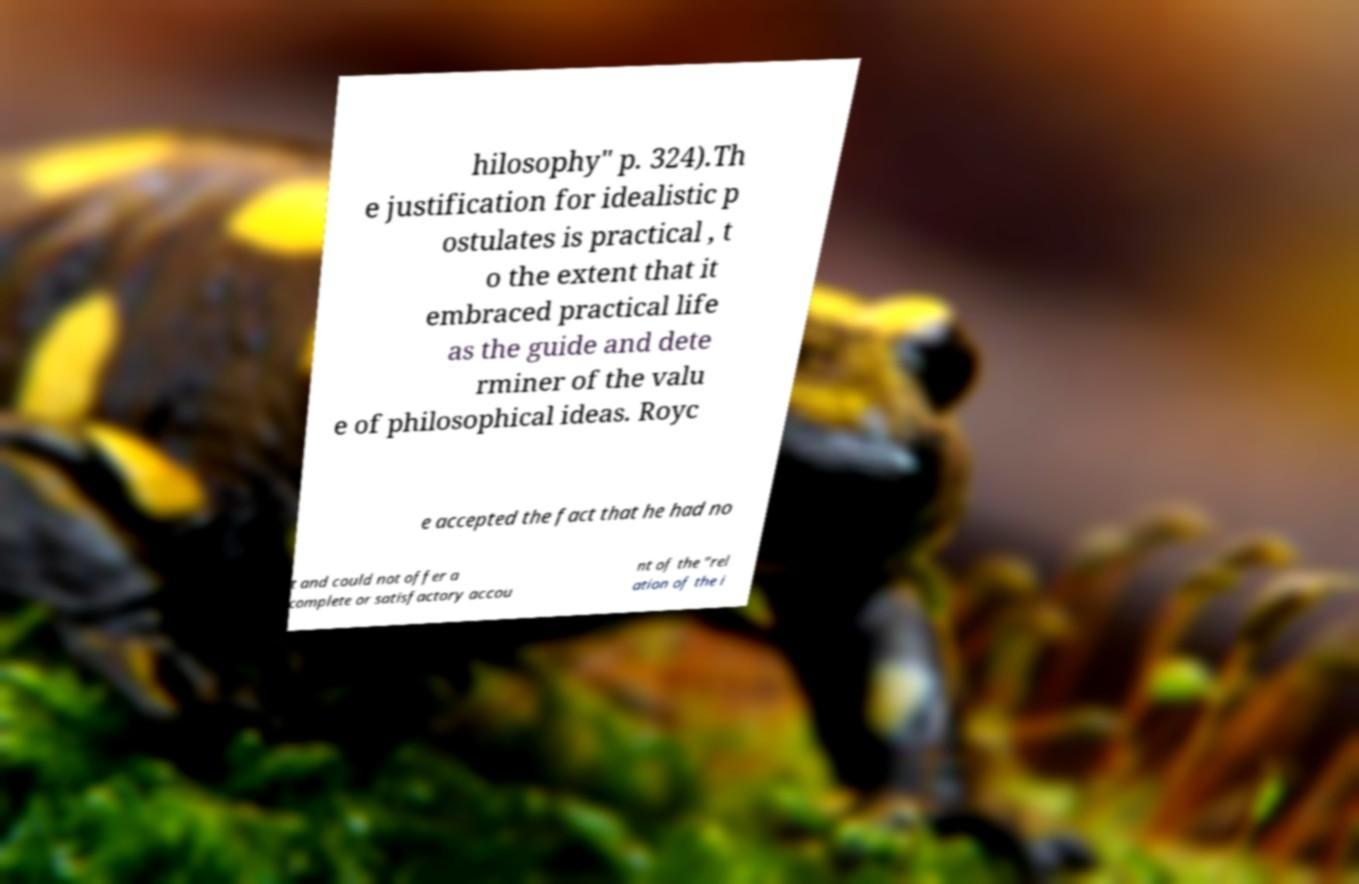Can you accurately transcribe the text from the provided image for me? hilosophy" p. 324).Th e justification for idealistic p ostulates is practical , t o the extent that it embraced practical life as the guide and dete rminer of the valu e of philosophical ideas. Royc e accepted the fact that he had no t and could not offer a complete or satisfactory accou nt of the "rel ation of the i 